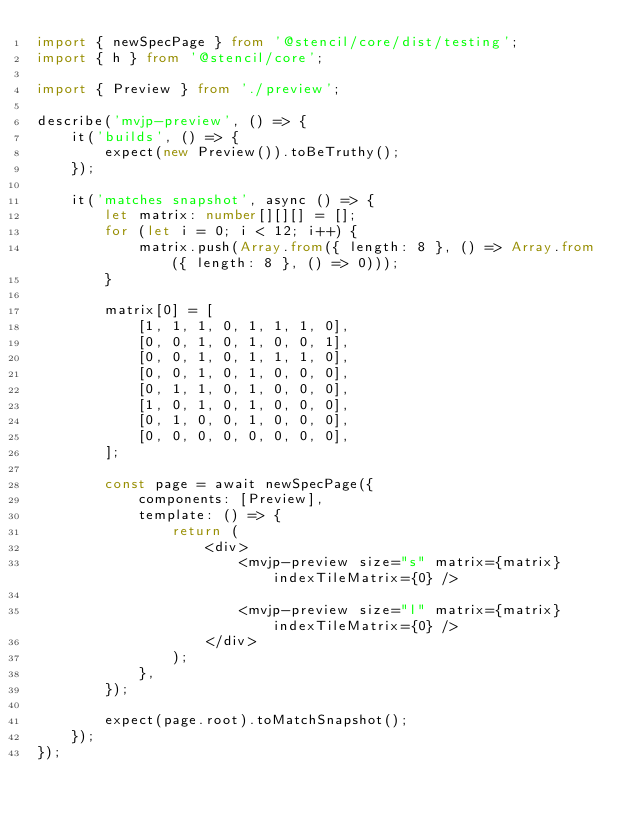Convert code to text. <code><loc_0><loc_0><loc_500><loc_500><_TypeScript_>import { newSpecPage } from '@stencil/core/dist/testing';
import { h } from '@stencil/core';

import { Preview } from './preview';

describe('mvjp-preview', () => {
    it('builds', () => {
        expect(new Preview()).toBeTruthy();
    });

    it('matches snapshot', async () => {
        let matrix: number[][][] = [];
        for (let i = 0; i < 12; i++) {
            matrix.push(Array.from({ length: 8 }, () => Array.from({ length: 8 }, () => 0)));
        }

        matrix[0] = [
            [1, 1, 1, 0, 1, 1, 1, 0],
            [0, 0, 1, 0, 1, 0, 0, 1],
            [0, 0, 1, 0, 1, 1, 1, 0],
            [0, 0, 1, 0, 1, 0, 0, 0],
            [0, 1, 1, 0, 1, 0, 0, 0],
            [1, 0, 1, 0, 1, 0, 0, 0],
            [0, 1, 0, 0, 1, 0, 0, 0],
            [0, 0, 0, 0, 0, 0, 0, 0],
        ];

        const page = await newSpecPage({
            components: [Preview],
            template: () => {
                return (
                    <div>
                        <mvjp-preview size="s" matrix={matrix} indexTileMatrix={0} />

                        <mvjp-preview size="l" matrix={matrix} indexTileMatrix={0} />
                    </div>
                );
            },
        });

        expect(page.root).toMatchSnapshot();
    });
});
</code> 